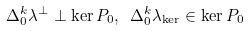Convert formula to latex. <formula><loc_0><loc_0><loc_500><loc_500>\Delta _ { 0 } ^ { k } \lambda ^ { \perp } \perp \ker P _ { 0 } , \ \Delta _ { 0 } ^ { k } \lambda _ { \ker } \in \ker P _ { 0 }</formula> 